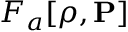<formula> <loc_0><loc_0><loc_500><loc_500>F _ { a } [ \rho , { P } ]</formula> 